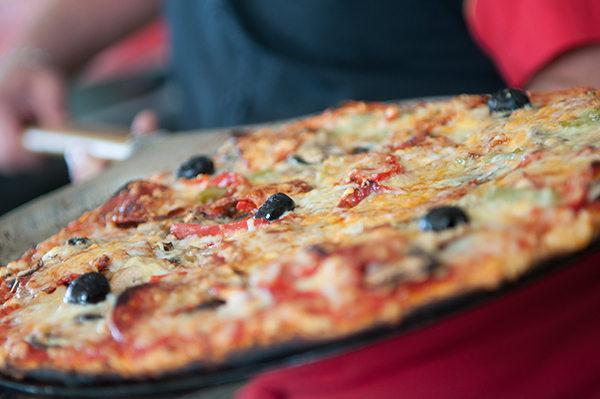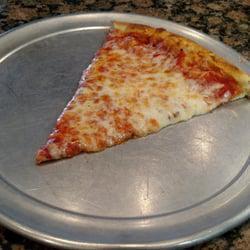The first image is the image on the left, the second image is the image on the right. Considering the images on both sides, is "One image shows a whole pizza, and the other image shows a pizza on a round gray tray, with multiple slices missing." valid? Answer yes or no. Yes. The first image is the image on the left, the second image is the image on the right. For the images shown, is this caption "The pizza in the image on the right is topped with round pepperoni slices." true? Answer yes or no. No. 